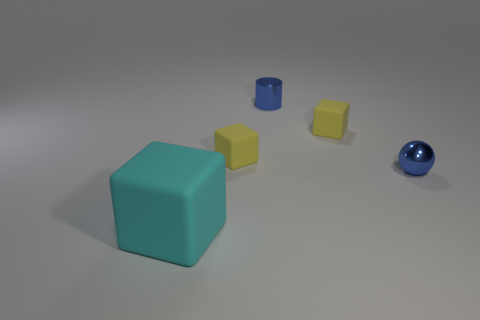Add 2 cyan metallic cylinders. How many objects exist? 7 Subtract all cubes. How many objects are left? 2 Subtract 0 cyan cylinders. How many objects are left? 5 Subtract all metal things. Subtract all big cyan rubber cubes. How many objects are left? 2 Add 1 small blue shiny objects. How many small blue shiny objects are left? 3 Add 2 yellow things. How many yellow things exist? 4 